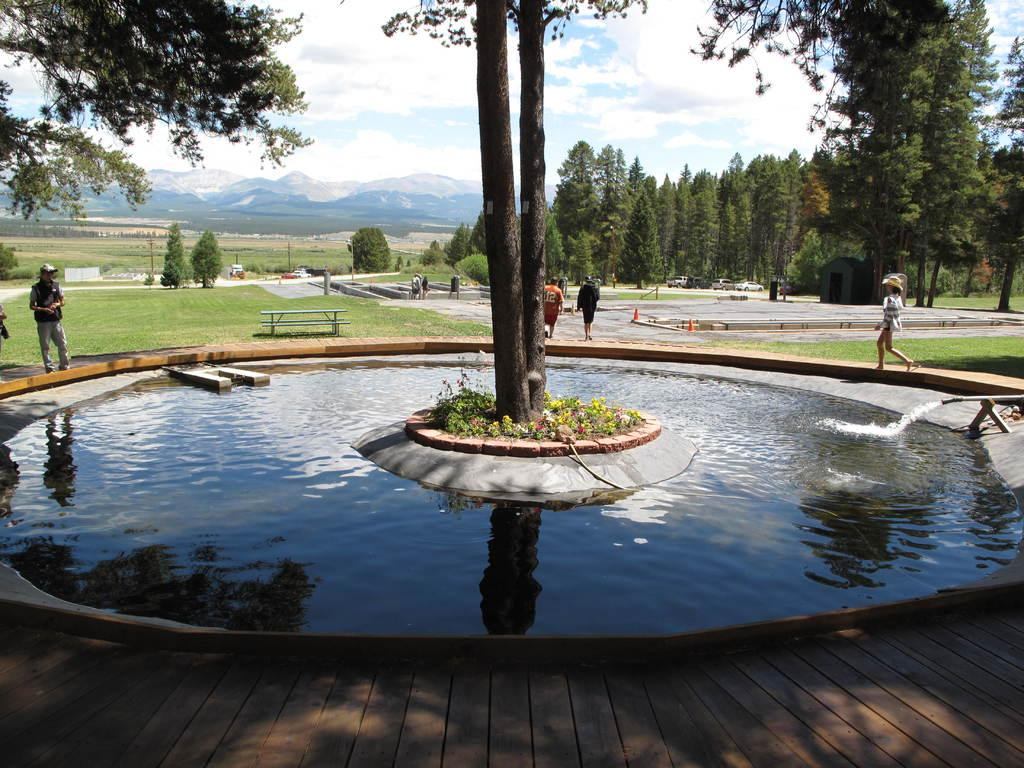What is the primary element visible in the image? There is water in the image. What structure can be seen in the image? There is a pipe in the image. What type of vegetation is present in the image? There are trees, plants, and flowers in the image. Are there any people in the image? Yes, there are people in the image. What type of furniture is visible in the image? There is a table and benches in the image. What is the natural setting visible in the image? There is grass, trees, hills, and sky visible in the background of the image. How many bananas are hanging from the trees in the image? There are no bananas visible in the image; only trees, plants, and flowers are present. What type of slip can be seen on the people's feet in the image? There is no indication of footwear or any type of slip in the image. 